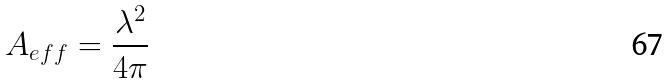<formula> <loc_0><loc_0><loc_500><loc_500>A _ { e f f } = \frac { \lambda ^ { 2 } } { 4 \pi }</formula> 